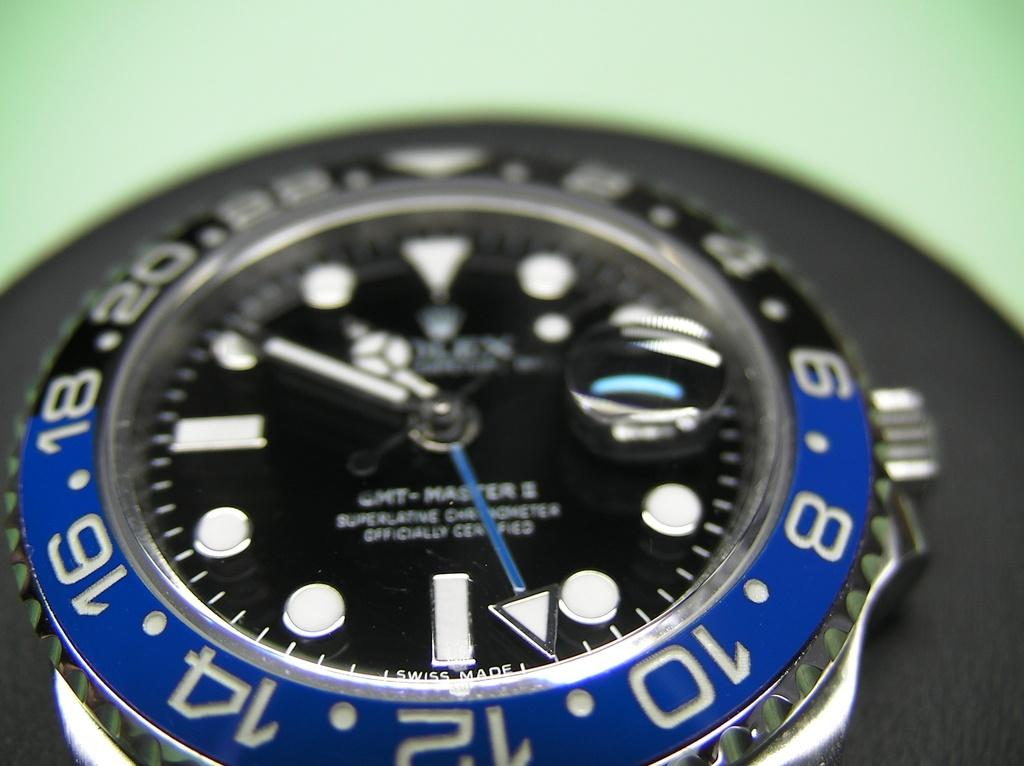<image>
Provide a brief description of the given image. A watch is OFFICIAL CERTIFIED according to text written on its face. 